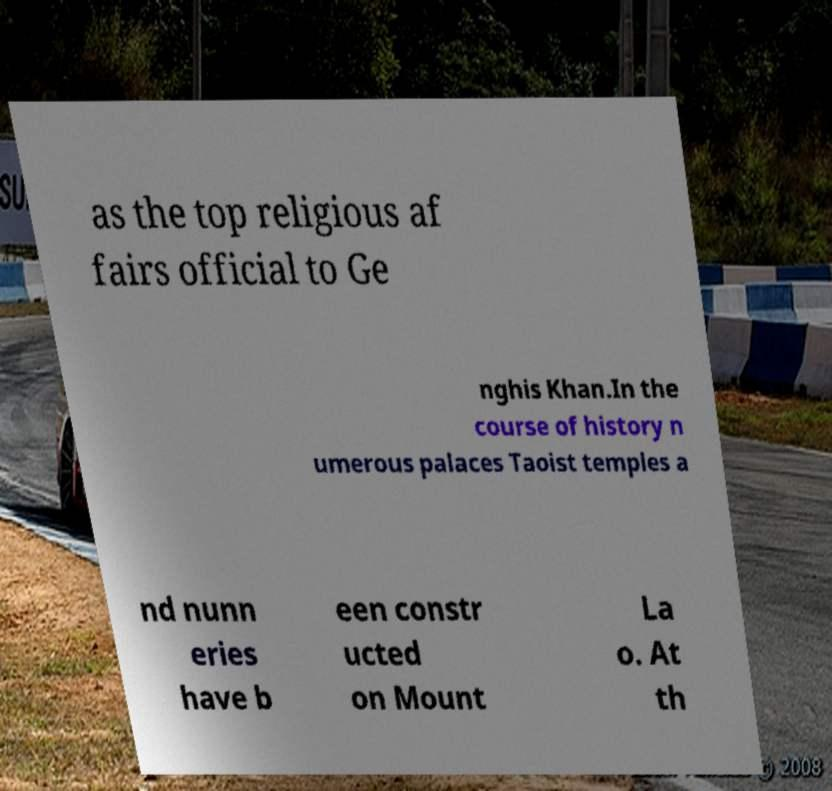I need the written content from this picture converted into text. Can you do that? as the top religious af fairs official to Ge nghis Khan.In the course of history n umerous palaces Taoist temples a nd nunn eries have b een constr ucted on Mount La o. At th 